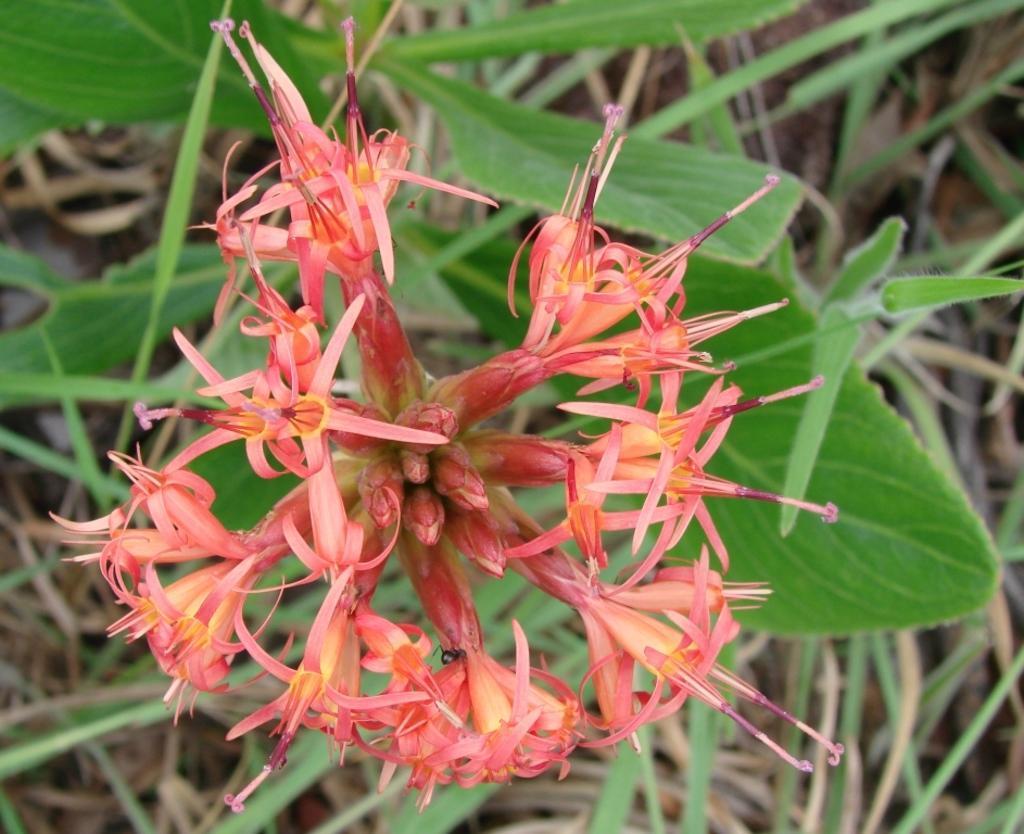Describe this image in one or two sentences. In this image, we can see some flowers and leaves. 